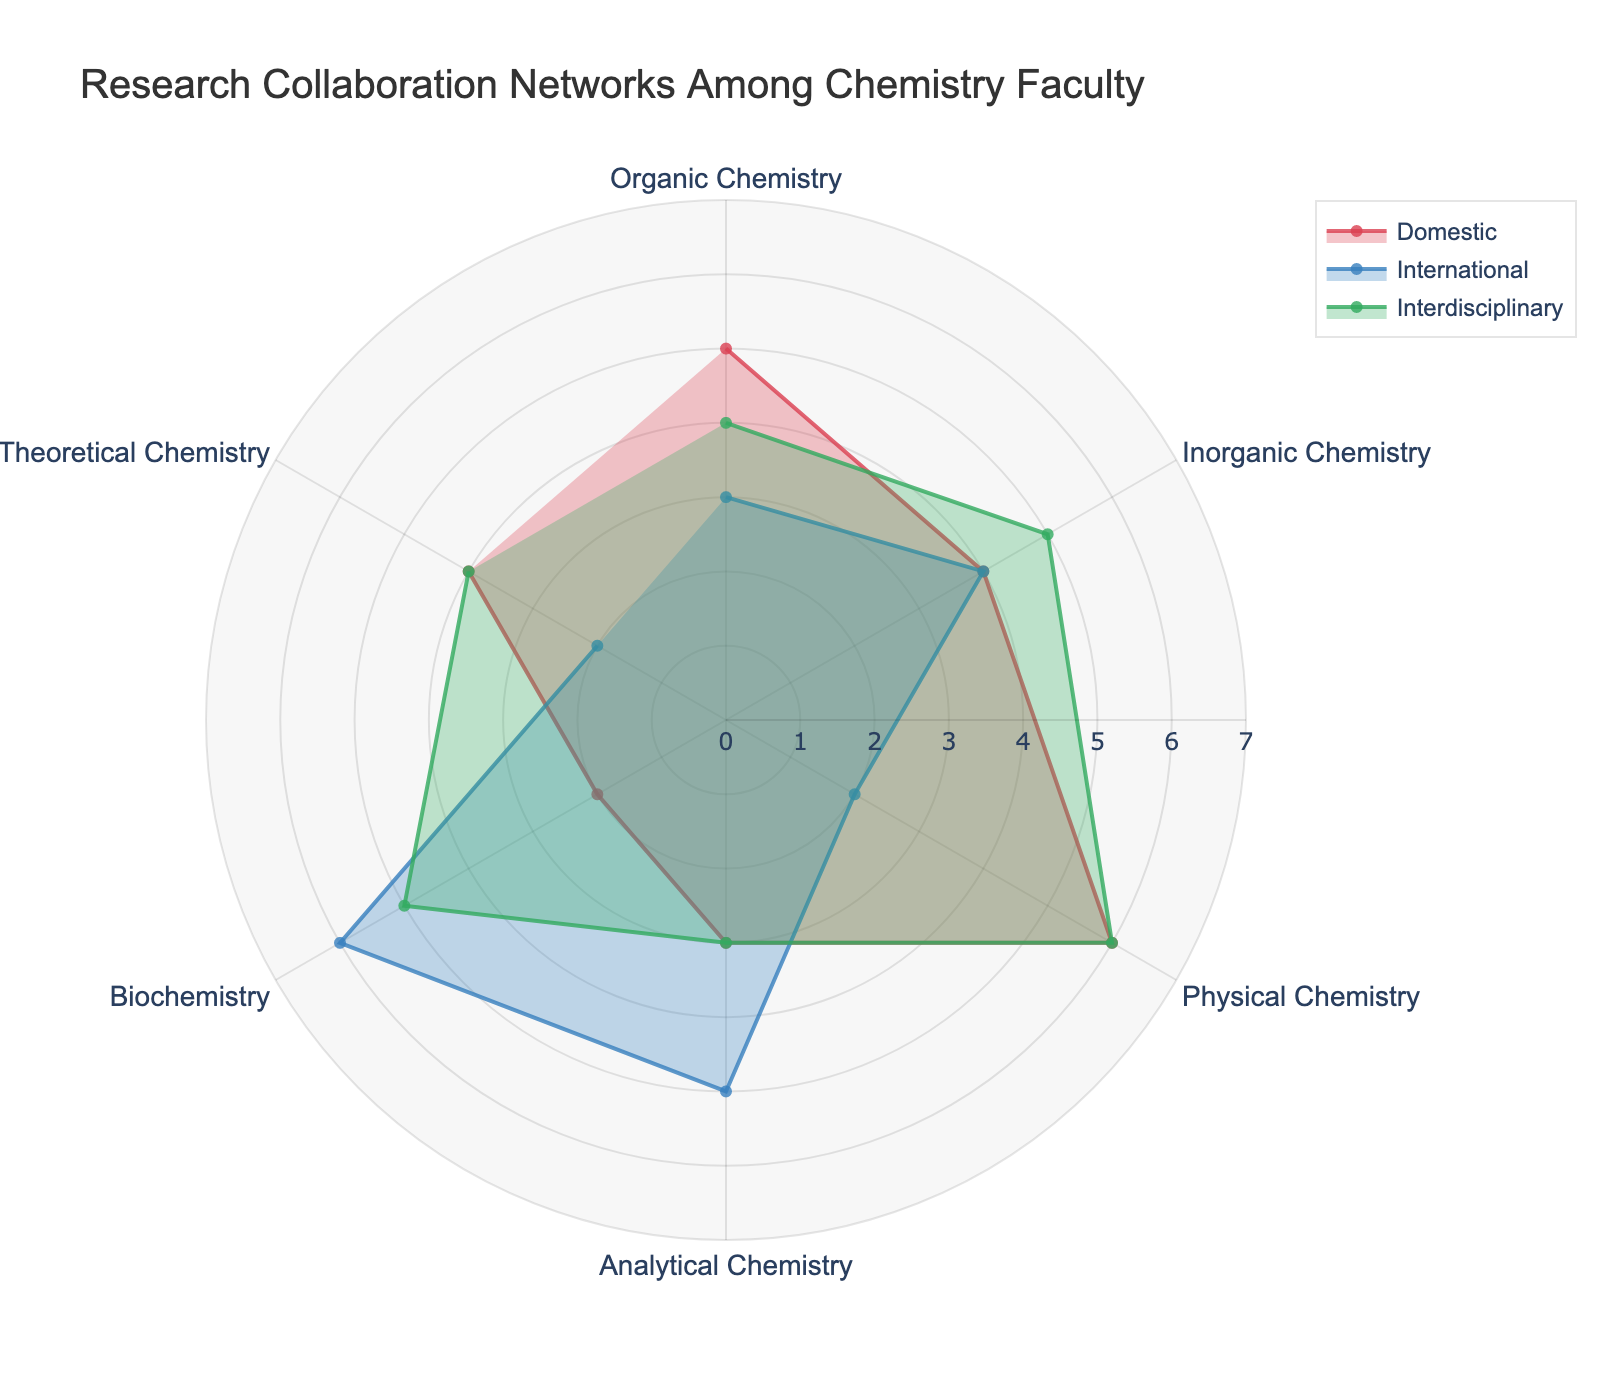What's the category with the most domestic collaborations? According to the figure, the category with the highest value in red (domestic collaborations) is Physical Chemistry with a value of 6.
Answer: Physical Chemistry How many categories have more international collaborations than domestic collaborations? By examining the plot, we see that Analytical Chemistry and Biochemistry have higher blue (international) than red (domestic) values.
Answer: 2 Which category has equal domestic and interdisciplinary collaborations? Looking at the red and green radial distances, Theoretical Chemistry shows an equal value of 4 for both domestic and interdisciplinary collaborations.
Answer: Theoretical Chemistry What is the sum of domestic and interdisciplinary collaborations for Inorganic Chemistry? Summing the red (domestic) and green (interdisciplinary) values for Inorganic Chemistry gives 4 + 5 = 9.
Answer: 9 What are the major collaboration trends in Biochemistry? In Biochemistry, the international collaborations have the highest value at 6 (blue), followed by interdisciplinary at 5 (green), and domestic at 2 (red). This indicates that Biochemistry has a strong international collaboration network.
Answer: Strong international collaboration Which categories have the highest interdisciplinary collaborations? From the chart, both Physical Chemistry and Biochemistry have the highest values in green (interdisciplinary), which is 6.
Answer: Physical Chemistry and Biochemistry Of all the collaboration types, which one shows the highest individual bar value on the chart? The highest individual bar value on the chart is 6, which appears in both blue (international) for Biochemistry and green (interdisciplinary) for Physical Chemistry and Biochemistry.
Answer: 6 Compare domestic collaborations of Organic Chemistry and Analytical Chemistry. Which is higher? The red radial distance for Organic Chemistry is 5, while for Analytical Chemistry it is 3, indicating Organic Chemistry has higher domestic collaborations.
Answer: Organic Chemistry What are the least collaborative categories in each type? For domestic (red): Biochemistry with 2. For international (blue): Theoretical Chemistry and Physical Chemistry both with 2. For interdisciplinary (green): Analytical Chemistry with 3.
Answer: Biochemistry (Domestic), Theoretical Chemistry & Physical Chemistry (International), Analytical Chemistry (Interdisciplinary) How many categories have an even number of domestic collaborations? From the red values, the categories with even values are Inorganic Chemistry (4), Biochemistry (2), and Theoretical Chemistry (4).
Answer: 3 